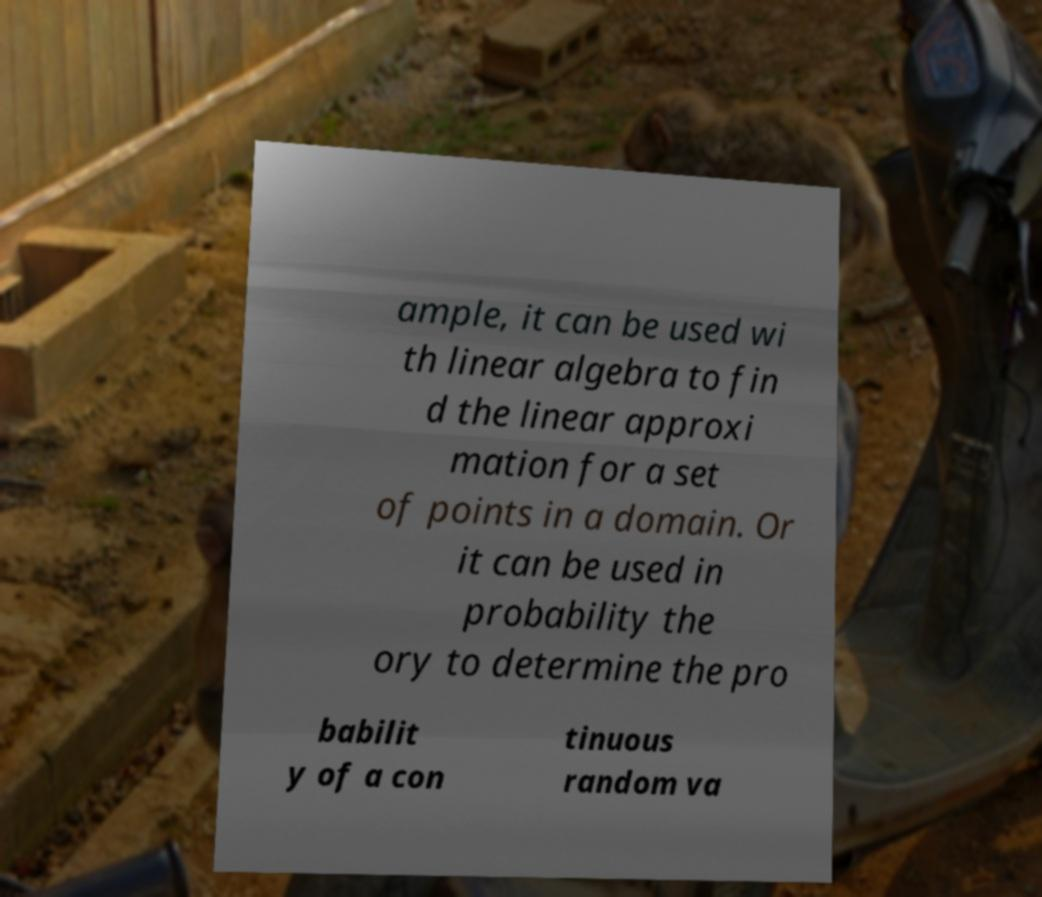What messages or text are displayed in this image? I need them in a readable, typed format. ample, it can be used wi th linear algebra to fin d the linear approxi mation for a set of points in a domain. Or it can be used in probability the ory to determine the pro babilit y of a con tinuous random va 